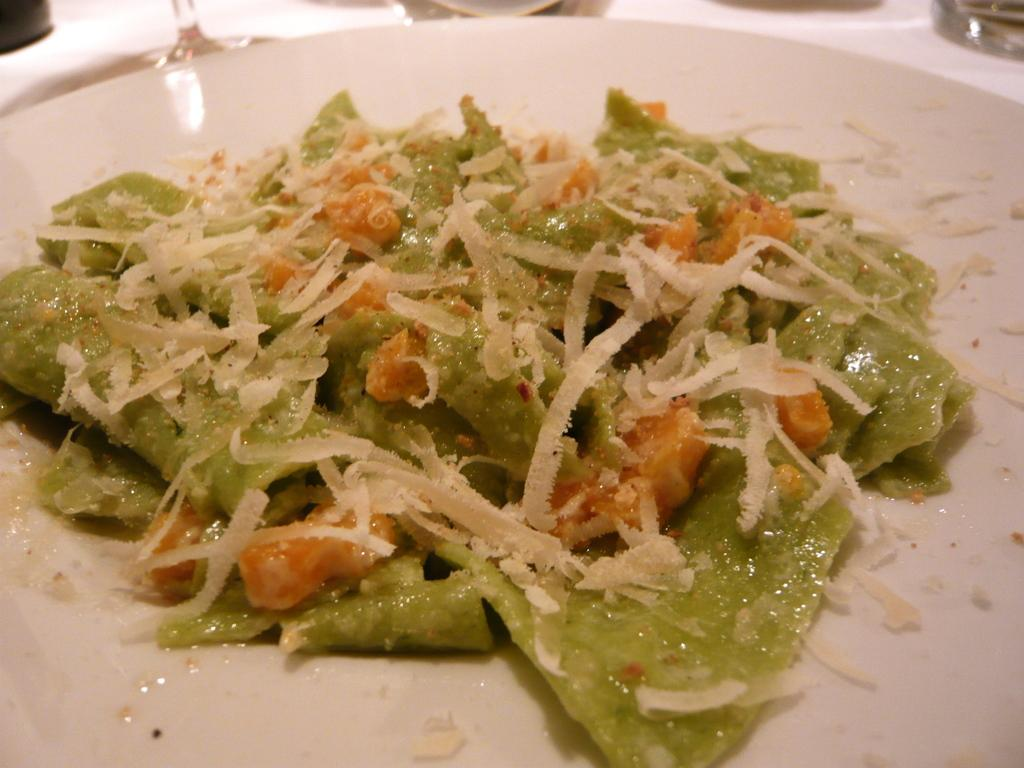What is on the plate that is visible in the image? There is a plate with food items in the image. Can you identify any other objects in the image besides the plate? There may be a glass in the image. Based on the presence of a plate with food items and possibly a glass, where might this image have been taken? The image is likely taken in a restaurant. What type of pencil can be seen in the image? There is no pencil present in the image. Can you describe the fangs of the creature in the image? There is no creature with fangs present in the image. 